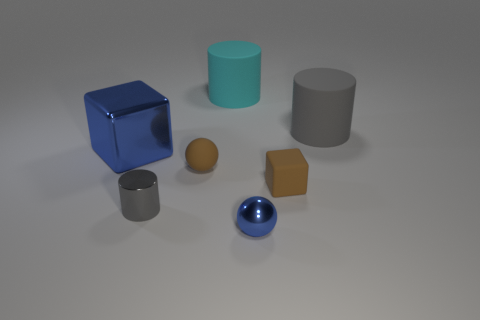Subtract all big cylinders. How many cylinders are left? 1 Subtract all cyan cylinders. How many cylinders are left? 2 Subtract all spheres. How many objects are left? 5 Subtract 1 blocks. How many blocks are left? 1 Subtract all cyan blocks. How many cyan cylinders are left? 1 Add 2 big cyan things. How many big cyan things are left? 3 Add 2 blue objects. How many blue objects exist? 4 Add 2 blue shiny balls. How many objects exist? 9 Subtract 1 cyan cylinders. How many objects are left? 6 Subtract all blue cylinders. Subtract all green cubes. How many cylinders are left? 3 